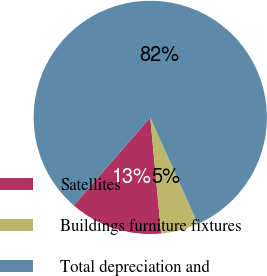Convert chart. <chart><loc_0><loc_0><loc_500><loc_500><pie_chart><fcel>Satellites<fcel>Buildings furniture fixtures<fcel>Total depreciation and<nl><fcel>12.88%<fcel>5.2%<fcel>81.92%<nl></chart> 